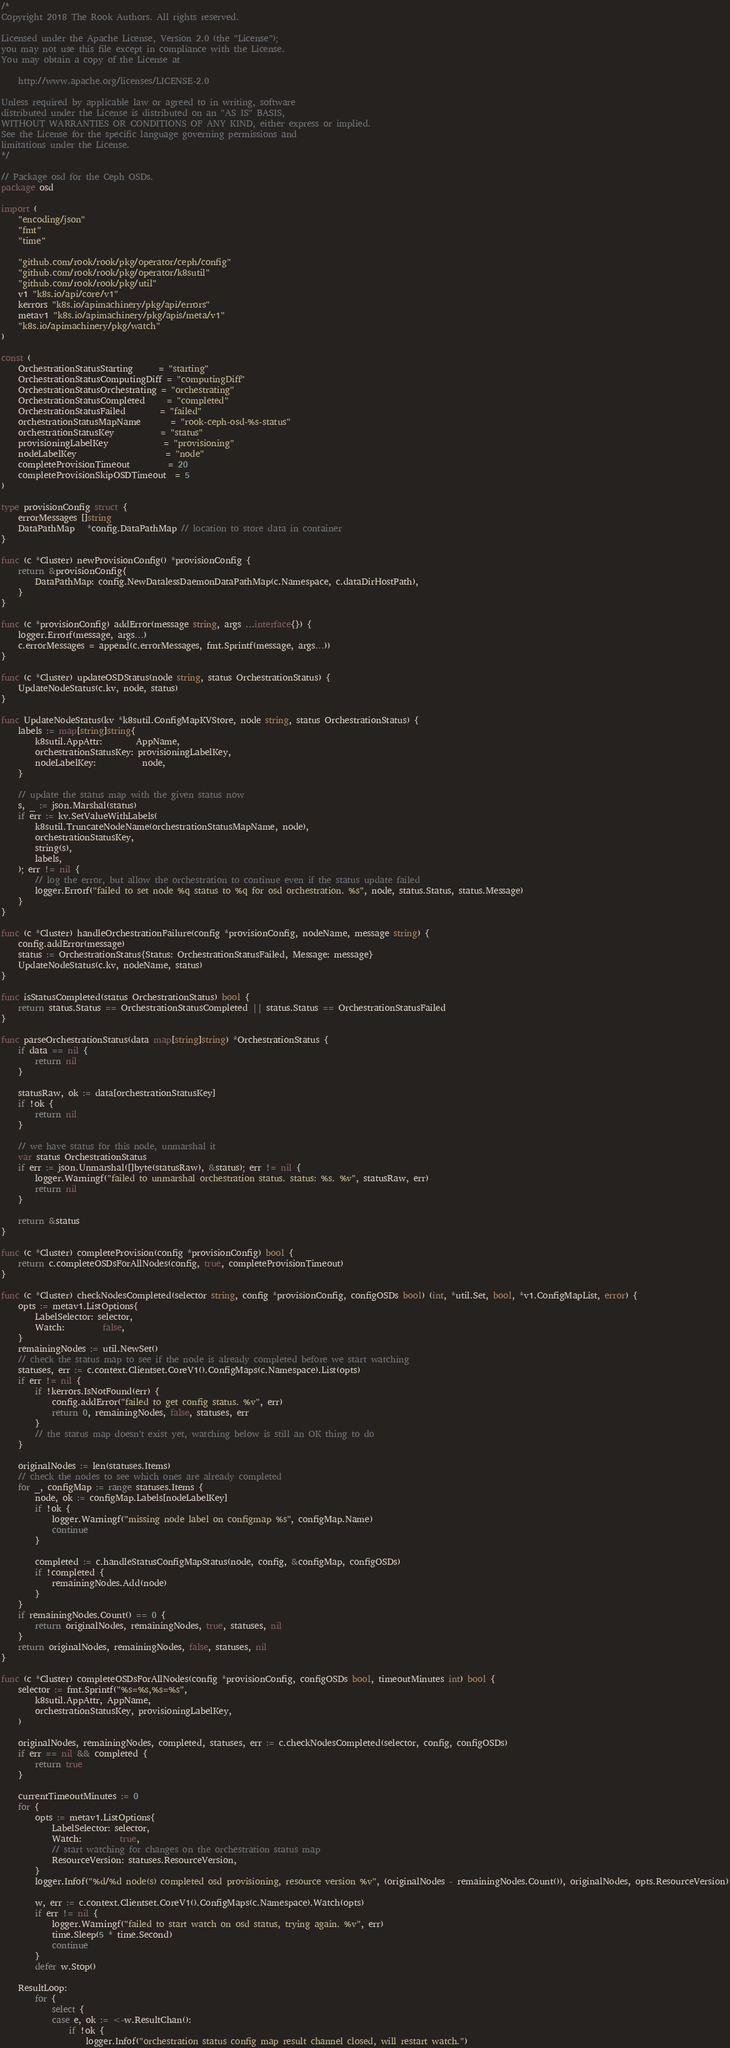<code> <loc_0><loc_0><loc_500><loc_500><_Go_>/*
Copyright 2018 The Rook Authors. All rights reserved.

Licensed under the Apache License, Version 2.0 (the "License");
you may not use this file except in compliance with the License.
You may obtain a copy of the License at

	http://www.apache.org/licenses/LICENSE-2.0

Unless required by applicable law or agreed to in writing, software
distributed under the License is distributed on an "AS IS" BASIS,
WITHOUT WARRANTIES OR CONDITIONS OF ANY KIND, either express or implied.
See the License for the specific language governing permissions and
limitations under the License.
*/

// Package osd for the Ceph OSDs.
package osd

import (
	"encoding/json"
	"fmt"
	"time"

	"github.com/rook/rook/pkg/operator/ceph/config"
	"github.com/rook/rook/pkg/operator/k8sutil"
	"github.com/rook/rook/pkg/util"
	v1 "k8s.io/api/core/v1"
	kerrors "k8s.io/apimachinery/pkg/api/errors"
	metav1 "k8s.io/apimachinery/pkg/apis/meta/v1"
	"k8s.io/apimachinery/pkg/watch"
)

const (
	OrchestrationStatusStarting      = "starting"
	OrchestrationStatusComputingDiff = "computingDiff"
	OrchestrationStatusOrchestrating = "orchestrating"
	OrchestrationStatusCompleted     = "completed"
	OrchestrationStatusFailed        = "failed"
	orchestrationStatusMapName       = "rook-ceph-osd-%s-status"
	orchestrationStatusKey           = "status"
	provisioningLabelKey             = "provisioning"
	nodeLabelKey                     = "node"
	completeProvisionTimeout         = 20
	completeProvisionSkipOSDTimeout  = 5
)

type provisionConfig struct {
	errorMessages []string
	DataPathMap   *config.DataPathMap // location to store data in container
}

func (c *Cluster) newProvisionConfig() *provisionConfig {
	return &provisionConfig{
		DataPathMap: config.NewDatalessDaemonDataPathMap(c.Namespace, c.dataDirHostPath),
	}
}

func (c *provisionConfig) addError(message string, args ...interface{}) {
	logger.Errorf(message, args...)
	c.errorMessages = append(c.errorMessages, fmt.Sprintf(message, args...))
}

func (c *Cluster) updateOSDStatus(node string, status OrchestrationStatus) {
	UpdateNodeStatus(c.kv, node, status)
}

func UpdateNodeStatus(kv *k8sutil.ConfigMapKVStore, node string, status OrchestrationStatus) {
	labels := map[string]string{
		k8sutil.AppAttr:        AppName,
		orchestrationStatusKey: provisioningLabelKey,
		nodeLabelKey:           node,
	}

	// update the status map with the given status now
	s, _ := json.Marshal(status)
	if err := kv.SetValueWithLabels(
		k8sutil.TruncateNodeName(orchestrationStatusMapName, node),
		orchestrationStatusKey,
		string(s),
		labels,
	); err != nil {
		// log the error, but allow the orchestration to continue even if the status update failed
		logger.Errorf("failed to set node %q status to %q for osd orchestration. %s", node, status.Status, status.Message)
	}
}

func (c *Cluster) handleOrchestrationFailure(config *provisionConfig, nodeName, message string) {
	config.addError(message)
	status := OrchestrationStatus{Status: OrchestrationStatusFailed, Message: message}
	UpdateNodeStatus(c.kv, nodeName, status)
}

func isStatusCompleted(status OrchestrationStatus) bool {
	return status.Status == OrchestrationStatusCompleted || status.Status == OrchestrationStatusFailed
}

func parseOrchestrationStatus(data map[string]string) *OrchestrationStatus {
	if data == nil {
		return nil
	}

	statusRaw, ok := data[orchestrationStatusKey]
	if !ok {
		return nil
	}

	// we have status for this node, unmarshal it
	var status OrchestrationStatus
	if err := json.Unmarshal([]byte(statusRaw), &status); err != nil {
		logger.Warningf("failed to unmarshal orchestration status. status: %s. %v", statusRaw, err)
		return nil
	}

	return &status
}

func (c *Cluster) completeProvision(config *provisionConfig) bool {
	return c.completeOSDsForAllNodes(config, true, completeProvisionTimeout)
}

func (c *Cluster) checkNodesCompleted(selector string, config *provisionConfig, configOSDs bool) (int, *util.Set, bool, *v1.ConfigMapList, error) {
	opts := metav1.ListOptions{
		LabelSelector: selector,
		Watch:         false,
	}
	remainingNodes := util.NewSet()
	// check the status map to see if the node is already completed before we start watching
	statuses, err := c.context.Clientset.CoreV1().ConfigMaps(c.Namespace).List(opts)
	if err != nil {
		if !kerrors.IsNotFound(err) {
			config.addError("failed to get config status. %v", err)
			return 0, remainingNodes, false, statuses, err
		}
		// the status map doesn't exist yet, watching below is still an OK thing to do
	}

	originalNodes := len(statuses.Items)
	// check the nodes to see which ones are already completed
	for _, configMap := range statuses.Items {
		node, ok := configMap.Labels[nodeLabelKey]
		if !ok {
			logger.Warningf("missing node label on configmap %s", configMap.Name)
			continue
		}

		completed := c.handleStatusConfigMapStatus(node, config, &configMap, configOSDs)
		if !completed {
			remainingNodes.Add(node)
		}
	}
	if remainingNodes.Count() == 0 {
		return originalNodes, remainingNodes, true, statuses, nil
	}
	return originalNodes, remainingNodes, false, statuses, nil
}

func (c *Cluster) completeOSDsForAllNodes(config *provisionConfig, configOSDs bool, timeoutMinutes int) bool {
	selector := fmt.Sprintf("%s=%s,%s=%s",
		k8sutil.AppAttr, AppName,
		orchestrationStatusKey, provisioningLabelKey,
	)

	originalNodes, remainingNodes, completed, statuses, err := c.checkNodesCompleted(selector, config, configOSDs)
	if err == nil && completed {
		return true
	}

	currentTimeoutMinutes := 0
	for {
		opts := metav1.ListOptions{
			LabelSelector: selector,
			Watch:         true,
			// start watching for changes on the orchestration status map
			ResourceVersion: statuses.ResourceVersion,
		}
		logger.Infof("%d/%d node(s) completed osd provisioning, resource version %v", (originalNodes - remainingNodes.Count()), originalNodes, opts.ResourceVersion)

		w, err := c.context.Clientset.CoreV1().ConfigMaps(c.Namespace).Watch(opts)
		if err != nil {
			logger.Warningf("failed to start watch on osd status, trying again. %v", err)
			time.Sleep(5 * time.Second)
			continue
		}
		defer w.Stop()

	ResultLoop:
		for {
			select {
			case e, ok := <-w.ResultChan():
				if !ok {
					logger.Infof("orchestration status config map result channel closed, will restart watch.")</code> 